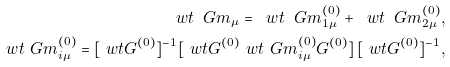<formula> <loc_0><loc_0><loc_500><loc_500>\ w t \ G m _ { \mu } = \ w t \ G m _ { 1 \mu } ^ { ( 0 ) } + \ w t \ G m _ { 2 \mu } ^ { ( 0 ) } , \\ \ w t \ G m _ { i \mu } ^ { ( 0 ) } = [ \ w t G ^ { ( 0 ) } ] ^ { - 1 } [ \ w t { G ^ { ( 0 ) } \ w t \ G m _ { i \mu } ^ { ( 0 ) } G ^ { ( 0 ) } } ] \, [ \ w t G ^ { ( 0 ) } ] ^ { - 1 } ,</formula> 